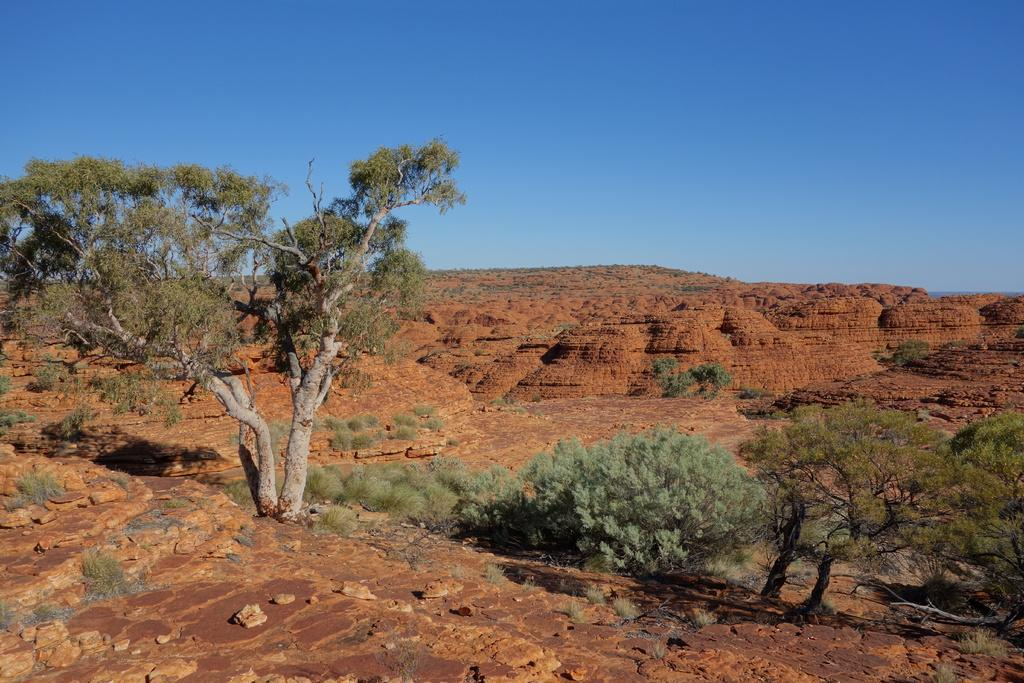Where was the image taken? The image was clicked outside. What can be seen in the foreground of the image? There are trees in the front of the image. What is present on the ground at the bottom of the image? Rocks are present on the ground at the bottom of the image. What is visible at the top of the image? The sky is visible at the top of the image. What is the color of the sky in the image? The sky is blue in color. What type of skirt is being worn by the tree in the image? There is no skirt present in the image, as the main subject is a tree. 